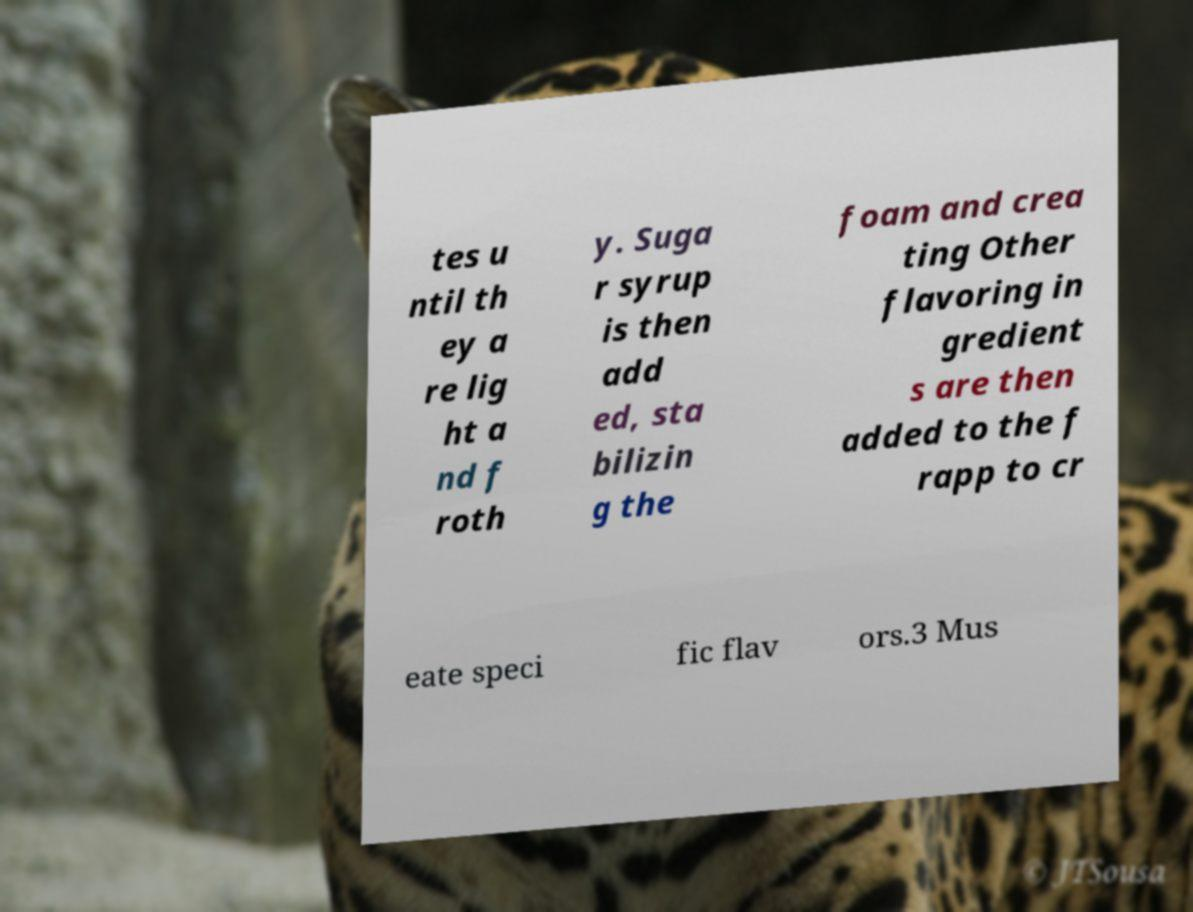Could you assist in decoding the text presented in this image and type it out clearly? tes u ntil th ey a re lig ht a nd f roth y. Suga r syrup is then add ed, sta bilizin g the foam and crea ting Other flavoring in gredient s are then added to the f rapp to cr eate speci fic flav ors.3 Mus 